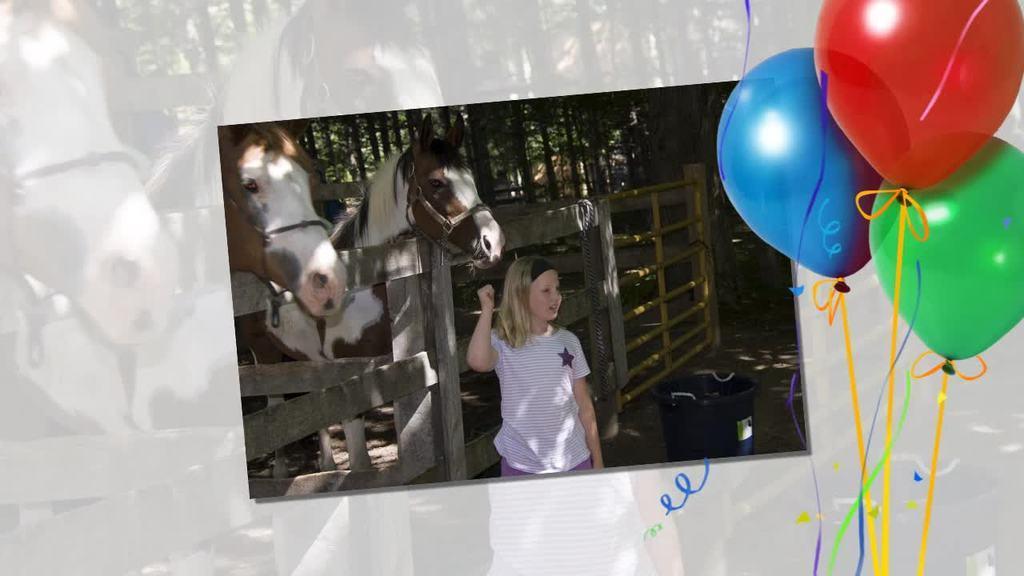Can you describe this image briefly? This is an edited image. In this image we can see there is a photo, beside the photo there are three balloons with ribbons. In the photo there is a girl standing and looking to the right side of the photo. On the other side of the photo there are two horses, in front of them there is a wooden fencing. In the background of the photo there are trees and there is a bin beside the girl. 